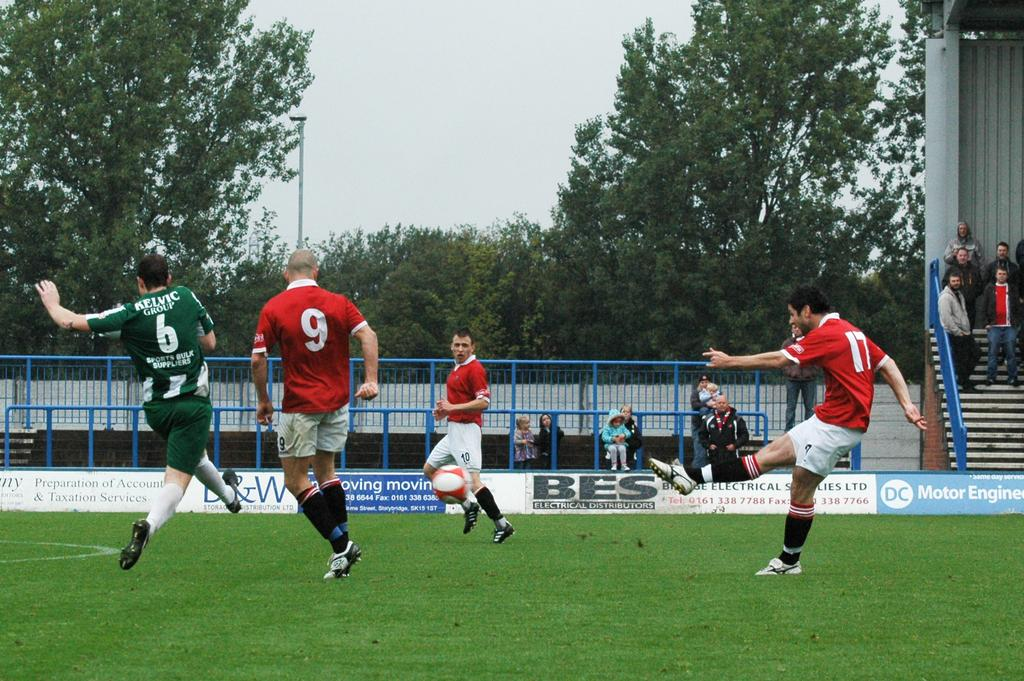<image>
Render a clear and concise summary of the photo. several people playing soccer with a BES advertisement 